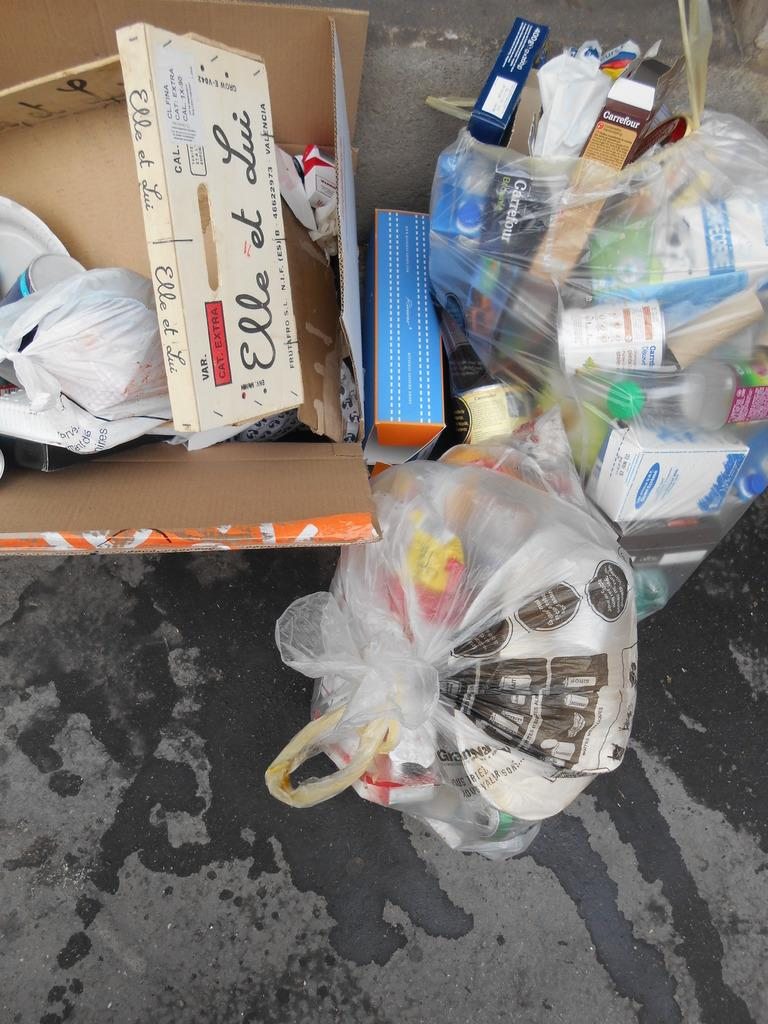What objects are made of plastic in the image? There are two plastic covers in the image. What is the color of the box on the left side of the image? The box is brown. Where are the plastic covers and the box located in the image? They are placed on the road. What is the condition of the road in the image? There is water on the road. How does the box show its appreciation for the plastic covers in the image? The box does not show any emotions or appreciation in the image, as it is an inanimate object. 